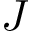<formula> <loc_0><loc_0><loc_500><loc_500>J</formula> 